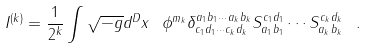Convert formula to latex. <formula><loc_0><loc_0><loc_500><loc_500>I ^ { ( k ) } = \frac { 1 } { 2 ^ { k } } \int \sqrt { - g } d ^ { D } x \ \phi ^ { m _ { k } } \delta ^ { a _ { 1 } b _ { 1 } \cdots a _ { k } b _ { k } } _ { c _ { 1 } d _ { 1 } \cdots c _ { k } d _ { k } } S ^ { c _ { 1 } d _ { 1 } } _ { a _ { 1 } b _ { 1 } } \cdots S ^ { c _ { k } d _ { k } } _ { a _ { k } b _ { k } } \ .</formula> 